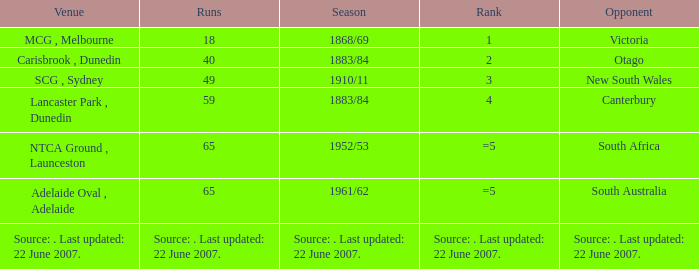Which Runs has a Opponent of south australia? 65.0. 